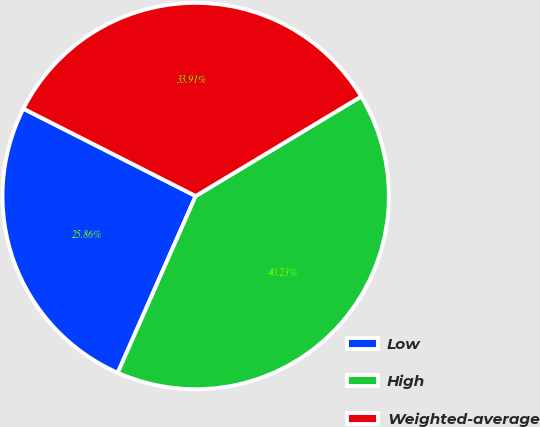Convert chart. <chart><loc_0><loc_0><loc_500><loc_500><pie_chart><fcel>Low<fcel>High<fcel>Weighted-average<nl><fcel>25.86%<fcel>40.23%<fcel>33.91%<nl></chart> 